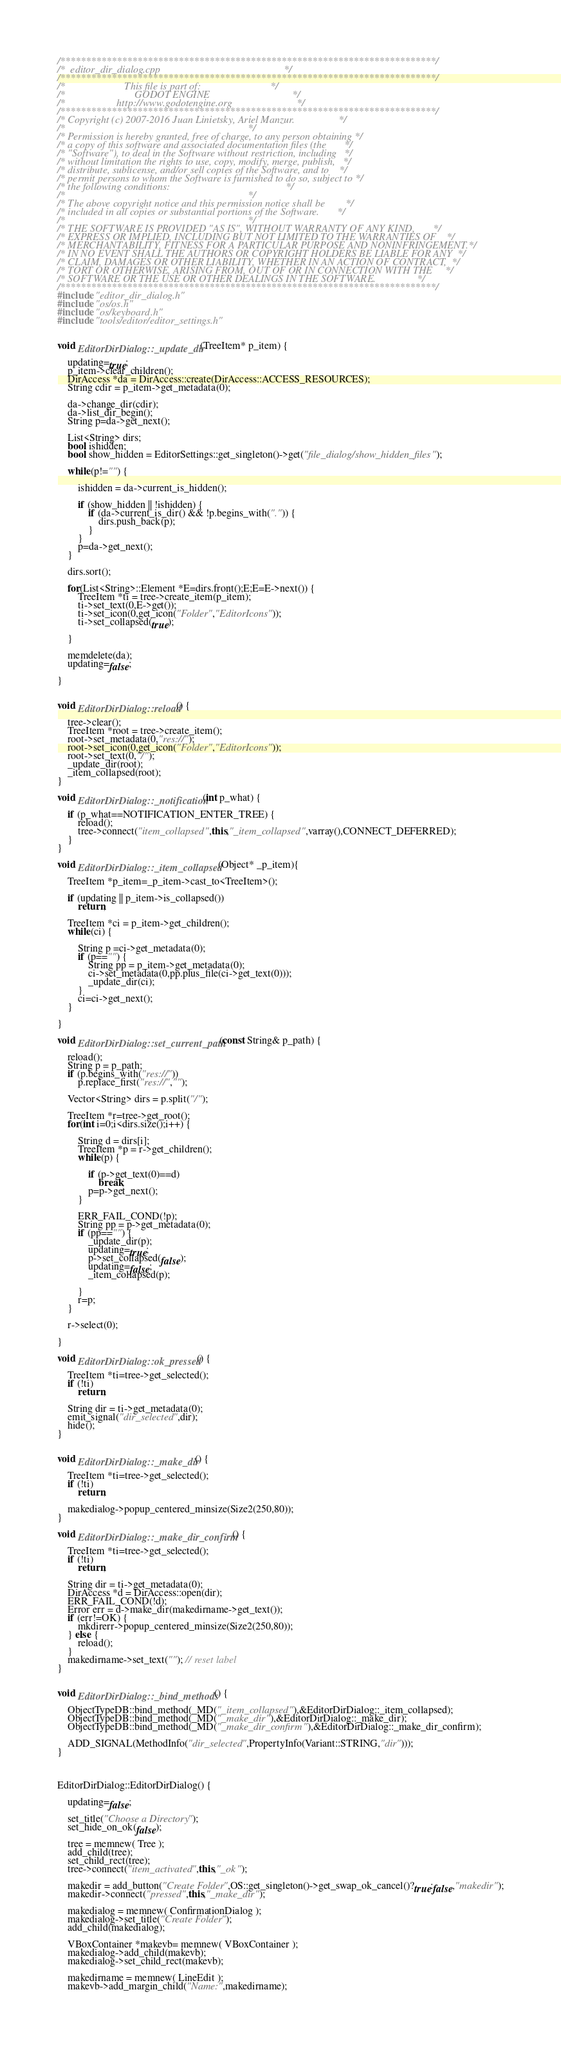Convert code to text. <code><loc_0><loc_0><loc_500><loc_500><_C++_>/*************************************************************************/
/*  editor_dir_dialog.cpp                                                */
/*************************************************************************/
/*                       This file is part of:                           */
/*                           GODOT ENGINE                                */
/*                    http://www.godotengine.org                         */
/*************************************************************************/
/* Copyright (c) 2007-2016 Juan Linietsky, Ariel Manzur.                 */
/*                                                                       */
/* Permission is hereby granted, free of charge, to any person obtaining */
/* a copy of this software and associated documentation files (the       */
/* "Software"), to deal in the Software without restriction, including   */
/* without limitation the rights to use, copy, modify, merge, publish,   */
/* distribute, sublicense, and/or sell copies of the Software, and to    */
/* permit persons to whom the Software is furnished to do so, subject to */
/* the following conditions:                                             */
/*                                                                       */
/* The above copyright notice and this permission notice shall be        */
/* included in all copies or substantial portions of the Software.       */
/*                                                                       */
/* THE SOFTWARE IS PROVIDED "AS IS", WITHOUT WARRANTY OF ANY KIND,       */
/* EXPRESS OR IMPLIED, INCLUDING BUT NOT LIMITED TO THE WARRANTIES OF    */
/* MERCHANTABILITY, FITNESS FOR A PARTICULAR PURPOSE AND NONINFRINGEMENT.*/
/* IN NO EVENT SHALL THE AUTHORS OR COPYRIGHT HOLDERS BE LIABLE FOR ANY  */
/* CLAIM, DAMAGES OR OTHER LIABILITY, WHETHER IN AN ACTION OF CONTRACT,  */
/* TORT OR OTHERWISE, ARISING FROM, OUT OF OR IN CONNECTION WITH THE     */
/* SOFTWARE OR THE USE OR OTHER DEALINGS IN THE SOFTWARE.                */
/*************************************************************************/
#include "editor_dir_dialog.h"
#include "os/os.h"
#include "os/keyboard.h"
#include "tools/editor/editor_settings.h"


void EditorDirDialog::_update_dir(TreeItem* p_item) {

	updating=true;
	p_item->clear_children();
	DirAccess *da = DirAccess::create(DirAccess::ACCESS_RESOURCES);
	String cdir = p_item->get_metadata(0);

	da->change_dir(cdir);
	da->list_dir_begin();
	String p=da->get_next();

	List<String> dirs;
	bool ishidden;
	bool show_hidden = EditorSettings::get_singleton()->get("file_dialog/show_hidden_files");

	while(p!="") {

		ishidden = da->current_is_hidden();

		if (show_hidden || !ishidden) {
			if (da->current_is_dir() && !p.begins_with(".")) {
				dirs.push_back(p);
			}
		}
		p=da->get_next();
	}

	dirs.sort();

	for(List<String>::Element *E=dirs.front();E;E=E->next()) {
		TreeItem *ti = tree->create_item(p_item);
		ti->set_text(0,E->get());
		ti->set_icon(0,get_icon("Folder","EditorIcons"));
		ti->set_collapsed(true);

	}

	memdelete(da);
	updating=false;

}


void EditorDirDialog::reload() {

	tree->clear();
	TreeItem *root = tree->create_item();
	root->set_metadata(0,"res://");
	root->set_icon(0,get_icon("Folder","EditorIcons"));
	root->set_text(0,"/");
	_update_dir(root);
	_item_collapsed(root);
}

void EditorDirDialog::_notification(int p_what) {

	if (p_what==NOTIFICATION_ENTER_TREE) {
		reload();
		tree->connect("item_collapsed",this,"_item_collapsed",varray(),CONNECT_DEFERRED);
	}
}

void EditorDirDialog::_item_collapsed(Object* _p_item){

	TreeItem *p_item=_p_item->cast_to<TreeItem>();

	if (updating || p_item->is_collapsed())
		return;

	TreeItem *ci = p_item->get_children();
	while(ci) {

		String p =ci->get_metadata(0);
		if (p=="") {
			String pp = p_item->get_metadata(0);
			ci->set_metadata(0,pp.plus_file(ci->get_text(0)));
			_update_dir(ci);
		}
		ci=ci->get_next();
	}

}

void EditorDirDialog::set_current_path(const String& p_path) {

	reload();
	String p = p_path;
	if (p.begins_with("res://"))
		p.replace_first("res://","");

	Vector<String> dirs = p.split("/");

	TreeItem *r=tree->get_root();
	for(int i=0;i<dirs.size();i++) {

		String d = dirs[i];
		TreeItem *p = r->get_children();
		while(p) {

			if (p->get_text(0)==d)
				break;
			p=p->get_next();
		}

		ERR_FAIL_COND(!p);
		String pp = p->get_metadata(0);
		if (pp=="") {
			_update_dir(p);
			updating=true;
			p->set_collapsed(false);
			updating=false;
			_item_collapsed(p);

		}
		r=p;
	}

	r->select(0);

}

void EditorDirDialog::ok_pressed() {

	TreeItem *ti=tree->get_selected();
	if (!ti)
		return;

	String dir = ti->get_metadata(0);
	emit_signal("dir_selected",dir);
	hide();
}


void EditorDirDialog::_make_dir() {

	TreeItem *ti=tree->get_selected();
	if (!ti)
		return;

	makedialog->popup_centered_minsize(Size2(250,80));
}

void EditorDirDialog::_make_dir_confirm() {

	TreeItem *ti=tree->get_selected();
	if (!ti)
		return;

	String dir = ti->get_metadata(0);
	DirAccess *d = DirAccess::open(dir);
	ERR_FAIL_COND(!d);
	Error err = d->make_dir(makedirname->get_text());
	if (err!=OK) {
		mkdirerr->popup_centered_minsize(Size2(250,80));
	} else {
		reload();
	}
	makedirname->set_text(""); // reset label
}


void EditorDirDialog::_bind_methods() {

	ObjectTypeDB::bind_method(_MD("_item_collapsed"),&EditorDirDialog::_item_collapsed);
	ObjectTypeDB::bind_method(_MD("_make_dir"),&EditorDirDialog::_make_dir);
	ObjectTypeDB::bind_method(_MD("_make_dir_confirm"),&EditorDirDialog::_make_dir_confirm);

	ADD_SIGNAL(MethodInfo("dir_selected",PropertyInfo(Variant::STRING,"dir")));
}



EditorDirDialog::EditorDirDialog() {

	updating=false;

	set_title("Choose a Directory");
	set_hide_on_ok(false);

	tree = memnew( Tree );
	add_child(tree);
	set_child_rect(tree);
	tree->connect("item_activated",this,"_ok");

	makedir = add_button("Create Folder",OS::get_singleton()->get_swap_ok_cancel()?true:false,"makedir");
	makedir->connect("pressed",this,"_make_dir");

	makedialog = memnew( ConfirmationDialog );
	makedialog->set_title("Create Folder");
	add_child(makedialog);

	VBoxContainer *makevb= memnew( VBoxContainer );
	makedialog->add_child(makevb);
	makedialog->set_child_rect(makevb);

	makedirname = memnew( LineEdit );
	makevb->add_margin_child("Name:",makedirname);</code> 